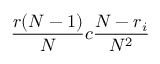<formula> <loc_0><loc_0><loc_500><loc_500>\frac { r ( N - 1 ) } { N } c \frac { N - r _ { i } } { N ^ { 2 } }</formula> 